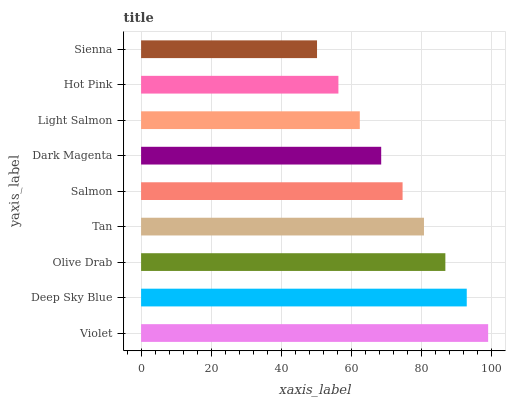Is Sienna the minimum?
Answer yes or no. Yes. Is Violet the maximum?
Answer yes or no. Yes. Is Deep Sky Blue the minimum?
Answer yes or no. No. Is Deep Sky Blue the maximum?
Answer yes or no. No. Is Violet greater than Deep Sky Blue?
Answer yes or no. Yes. Is Deep Sky Blue less than Violet?
Answer yes or no. Yes. Is Deep Sky Blue greater than Violet?
Answer yes or no. No. Is Violet less than Deep Sky Blue?
Answer yes or no. No. Is Salmon the high median?
Answer yes or no. Yes. Is Salmon the low median?
Answer yes or no. Yes. Is Deep Sky Blue the high median?
Answer yes or no. No. Is Violet the low median?
Answer yes or no. No. 